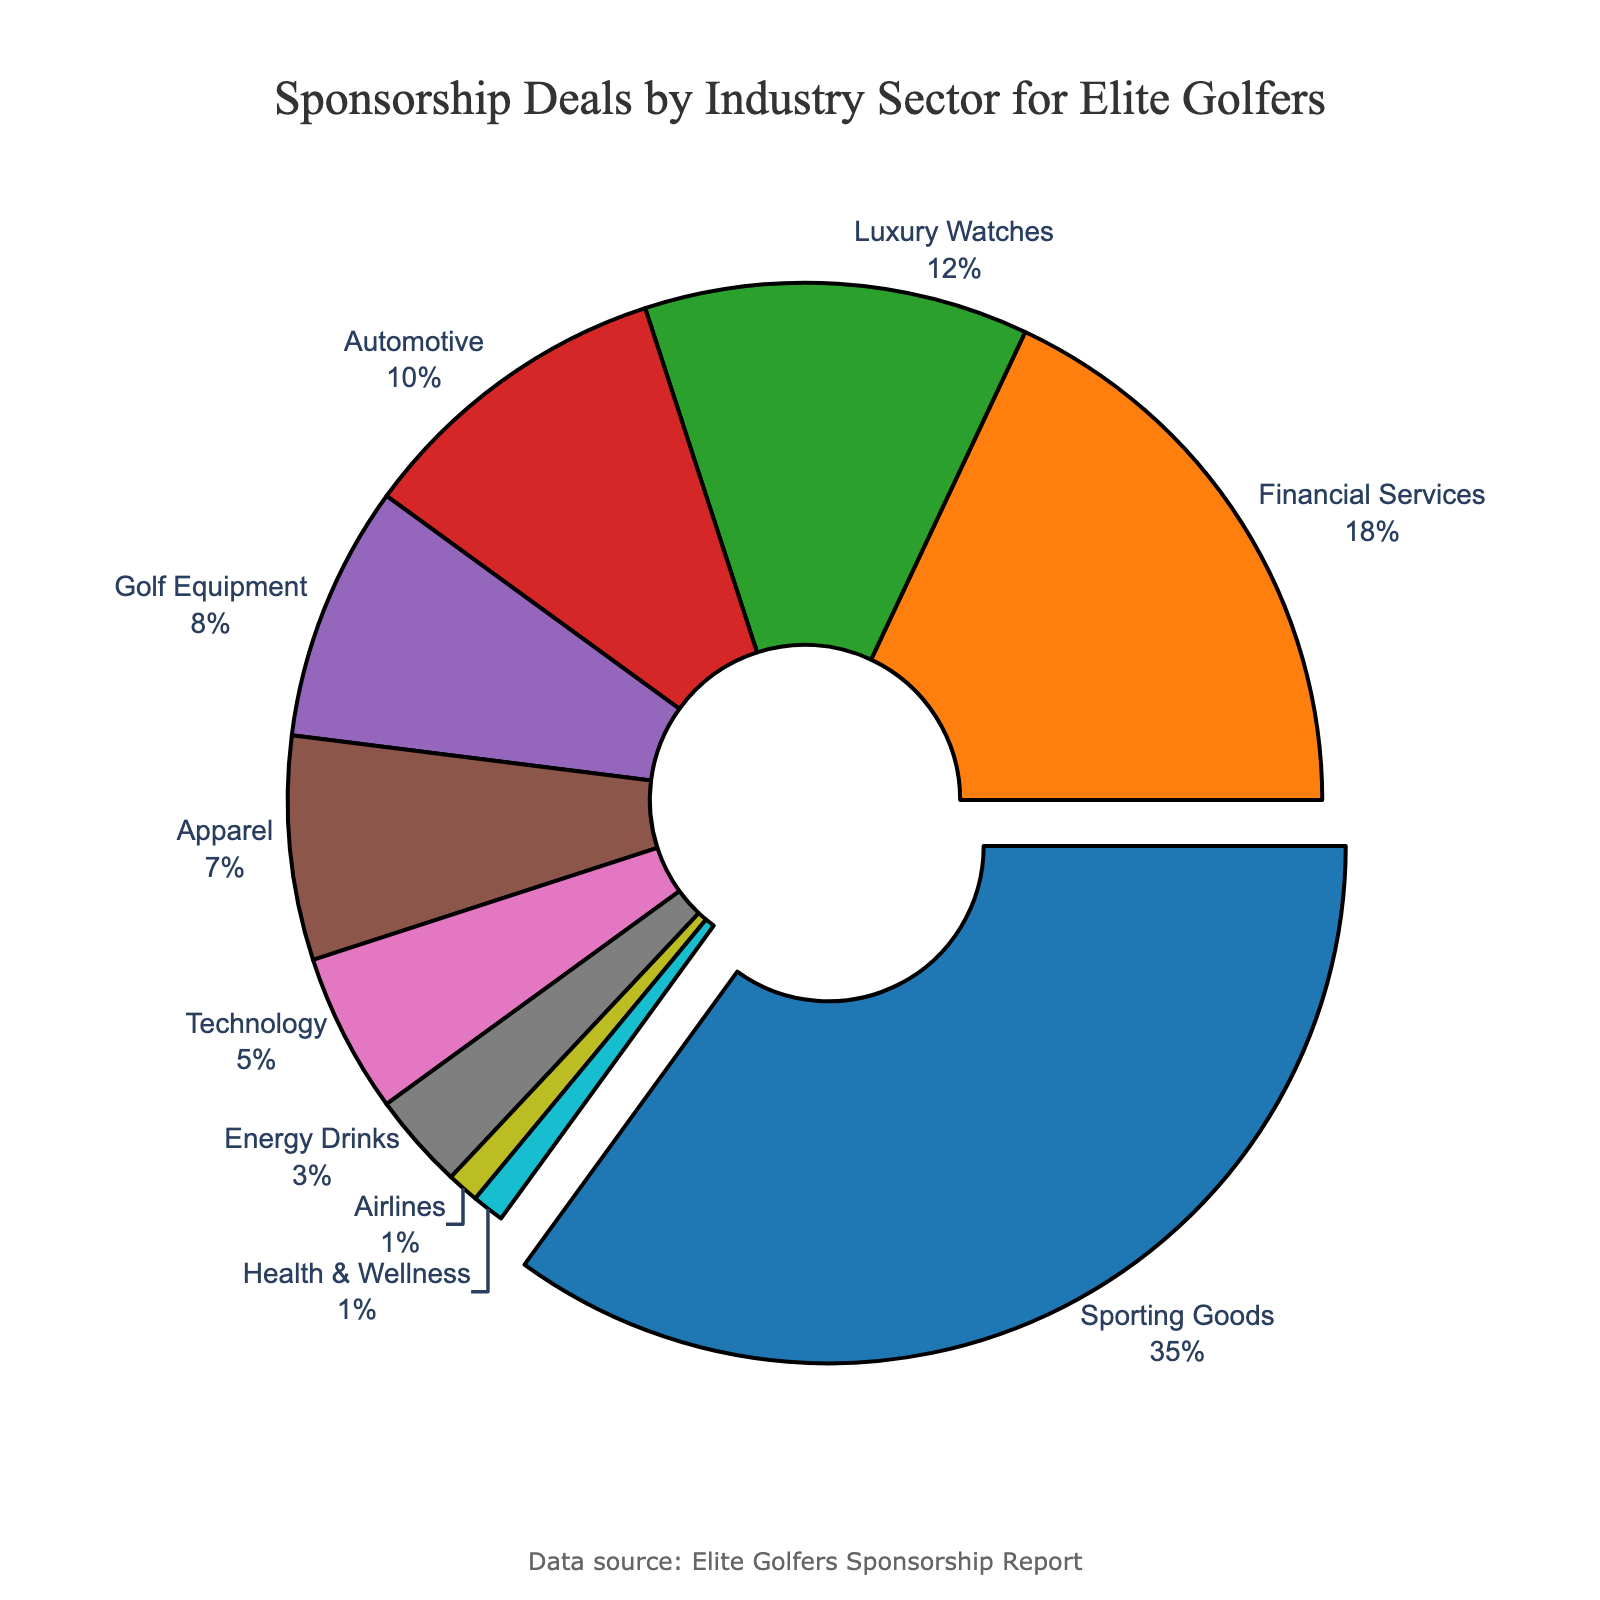Which industry sector has the highest percentage of sponsorship deals for elite golfers? The sector with the largest slice of the pie chart, visually distinct by being slightly pulled out, represents the highest percentage. In this case, it is Sporting Goods.
Answer: Sporting Goods What percentage of sponsorship deals comes from the Automotive and Golf Equipment sectors combined? Locate the segments for Automotive (10%) and Golf Equipment (8%) in the chart. Adding these percentages gives 10% + 8% = 18%.
Answer: 18% Which sector has a higher percentage of sponsorship deals, Financial Services or Luxury Watches? Compare the sizes of the pie chart segments for Financial Services (18%) and Luxury Watches (12%), with Financial Services being larger.
Answer: Financial Services What is the combined percentage of the smallest three sectors? The three smallest sectors are Airlines (1%), Health & Wellness (1%), and Energy Drinks (3%). Adding these percentages gives 1% + 1% + 3% = 5%.
Answer: 5% By how much does the Sporting Goods sector exceed the Technology sector in percentage? Calculate the difference between Sporting Goods (35%) and Technology (5%) sectors: 35% - 5% = 30%.
Answer: 30% Is the percentage of the Apparel sector less than that of the Golf Equipment sector? The chart shows Apparel at 7% and Golf Equipment at 8%, confirming Apparel is less.
Answer: Yes Which color represents the Luxury Watches sector? Identify the color corresponding to the Luxury Watches segment, which is the third listed sector. The color is green.
Answer: Green What's the total percentage of sectors that individually contribute less than 10% each? Summing the percentages for sectors under 10%: Golf Equipment (8%), Apparel (7%), Technology (5%), Energy Drinks (3%), Airlines (1%), Health & Wellness (1%). This equals 8% + 7% + 5% + 3% + 1% + 1% = 25%.
Answer: 25% How does the percentage of Financial Services compare to the sum of Technology and Energy Drinks sectors? Financial Services stands at 18%, while Technology is 5% and Energy Drinks 3%. Summing the latter gives 5% + 3% = 8%, which is smaller than 18%.
Answer: Financial Services is greater Is the combined percentage of the Apparel and Automotive sectors greater than the Sporting Goods sector? Apparel is 7% and Automotive is 10%, together 7% + 10% = 17%, which is less than 35% from Sporting Goods.
Answer: No 